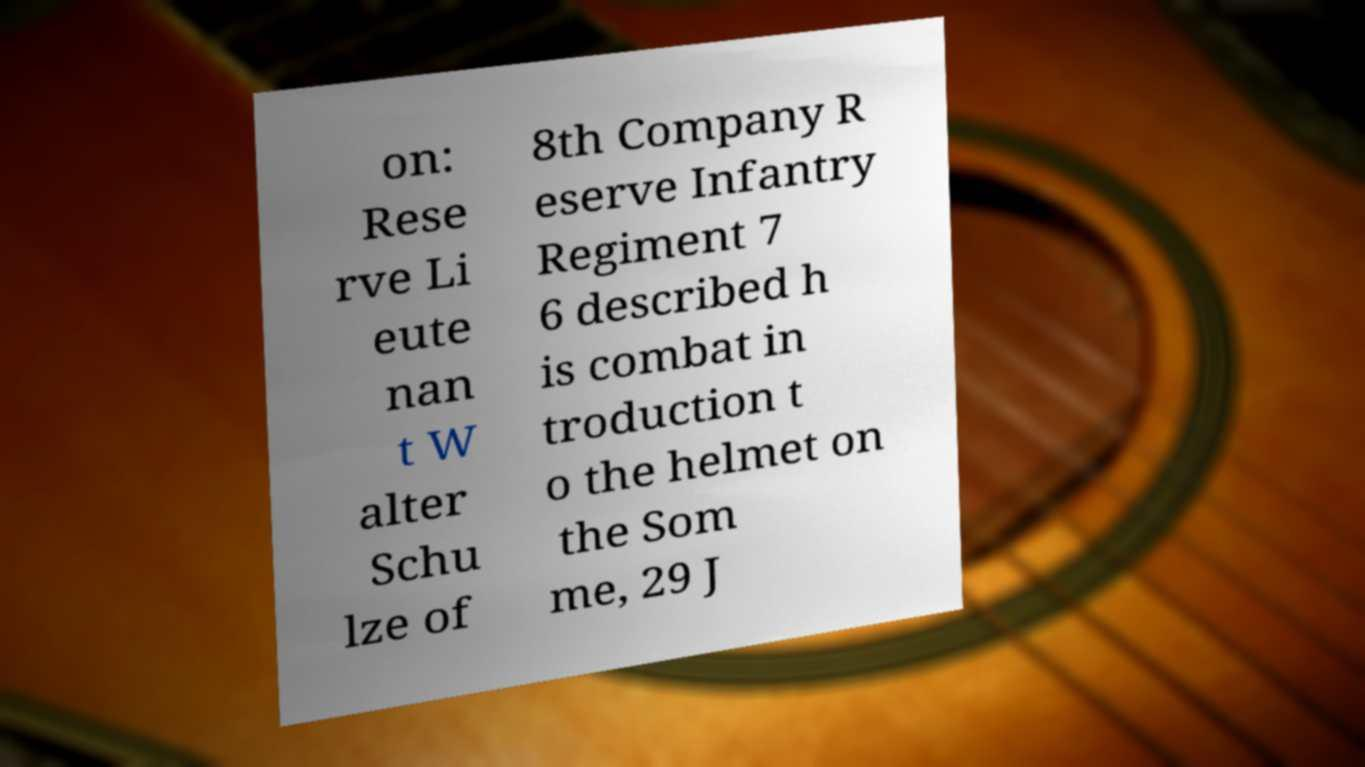Can you accurately transcribe the text from the provided image for me? on: Rese rve Li eute nan t W alter Schu lze of 8th Company R eserve Infantry Regiment 7 6 described h is combat in troduction t o the helmet on the Som me, 29 J 